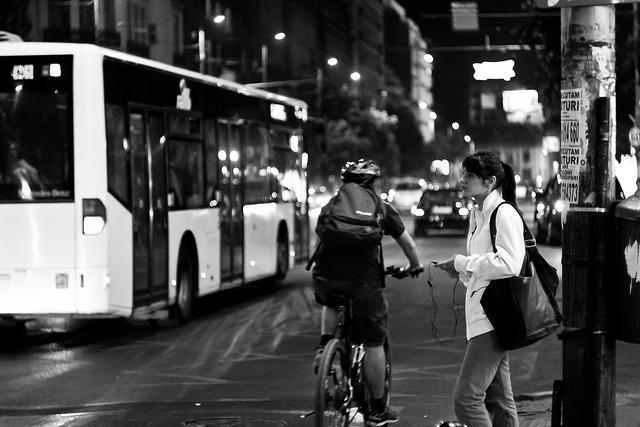How many people can you see?
Give a very brief answer. 2. How many handbags can you see?
Give a very brief answer. 2. 